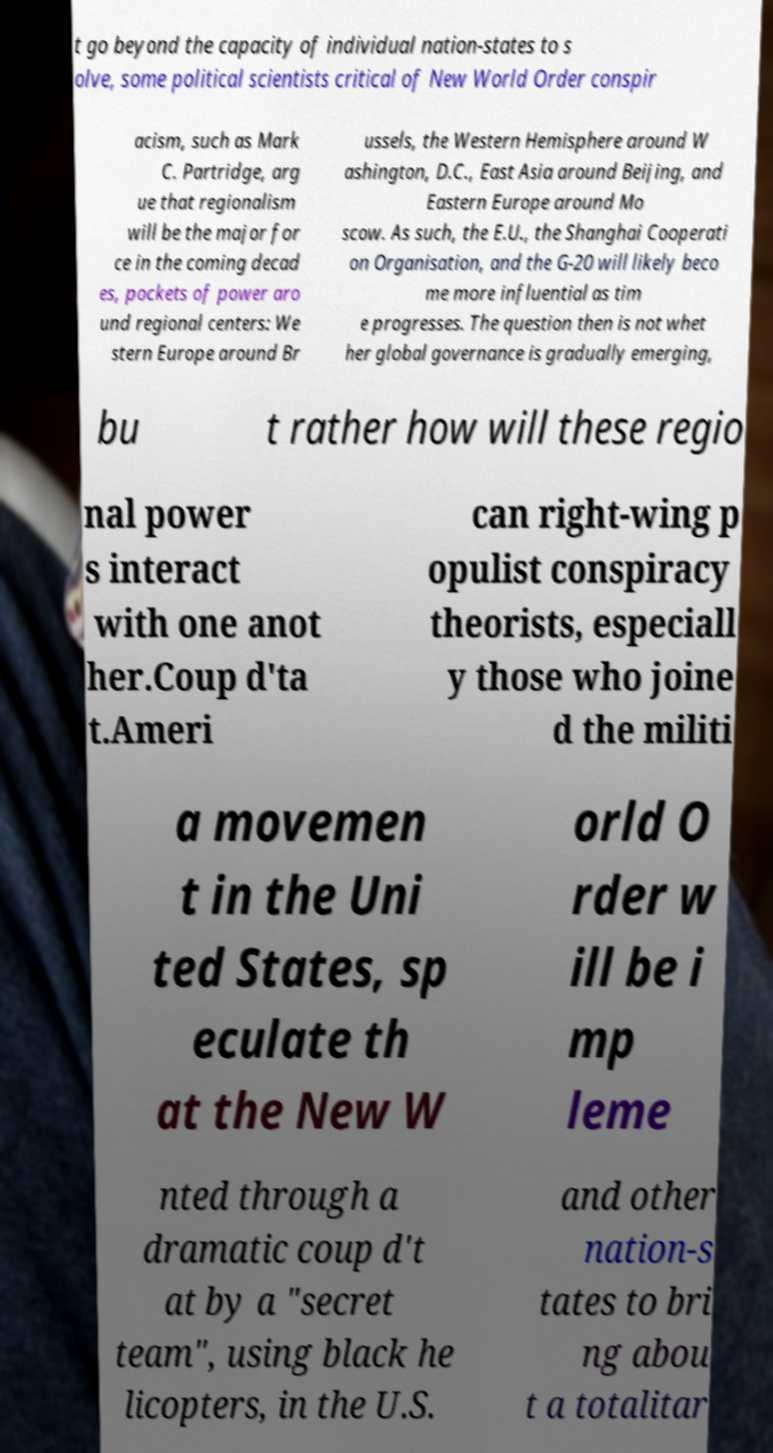Please read and relay the text visible in this image. What does it say? t go beyond the capacity of individual nation-states to s olve, some political scientists critical of New World Order conspir acism, such as Mark C. Partridge, arg ue that regionalism will be the major for ce in the coming decad es, pockets of power aro und regional centers: We stern Europe around Br ussels, the Western Hemisphere around W ashington, D.C., East Asia around Beijing, and Eastern Europe around Mo scow. As such, the E.U., the Shanghai Cooperati on Organisation, and the G-20 will likely beco me more influential as tim e progresses. The question then is not whet her global governance is gradually emerging, bu t rather how will these regio nal power s interact with one anot her.Coup d'ta t.Ameri can right-wing p opulist conspiracy theorists, especiall y those who joine d the militi a movemen t in the Uni ted States, sp eculate th at the New W orld O rder w ill be i mp leme nted through a dramatic coup d't at by a "secret team", using black he licopters, in the U.S. and other nation-s tates to bri ng abou t a totalitar 